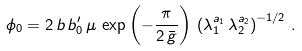Convert formula to latex. <formula><loc_0><loc_0><loc_500><loc_500>\phi _ { 0 } = 2 \, b \, b _ { 0 } ^ { \prime } \, \mu \, \exp \left ( - \frac { \pi } { 2 \, \bar { g } } \right ) \, \left ( \lambda _ { 1 } ^ { a _ { 1 } } \, \lambda _ { 2 } ^ { a _ { 2 } } \right ) ^ { - 1 / 2 } \, .</formula> 